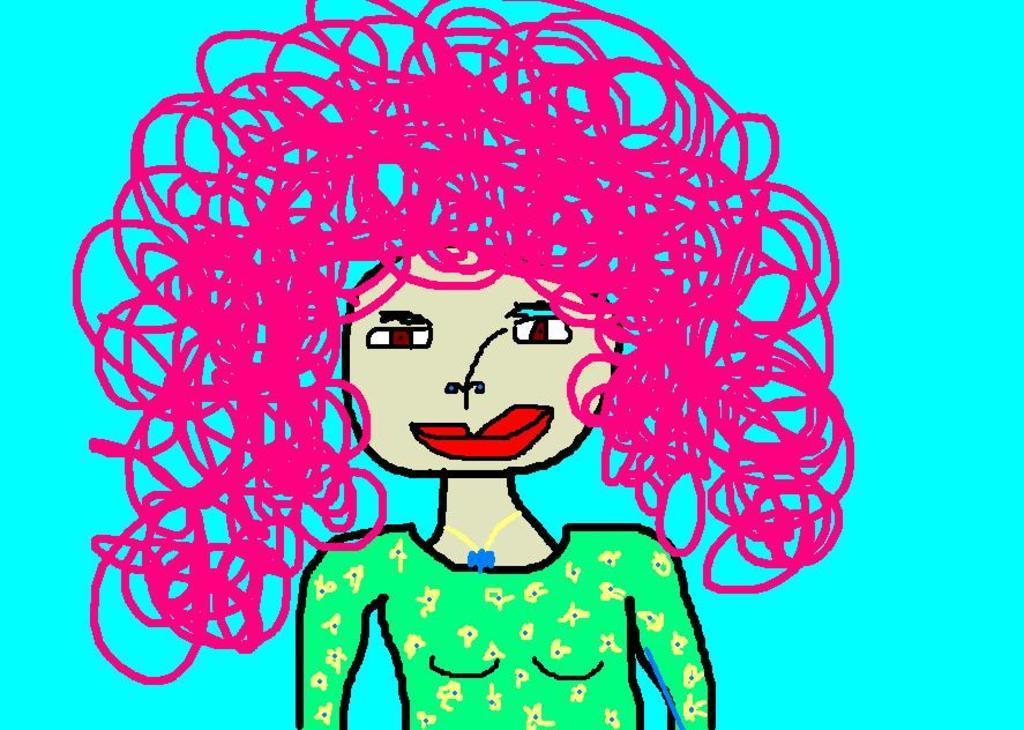Could you give a brief overview of what you see in this image? This image consists of an art of a woman. The background is blue in color. 